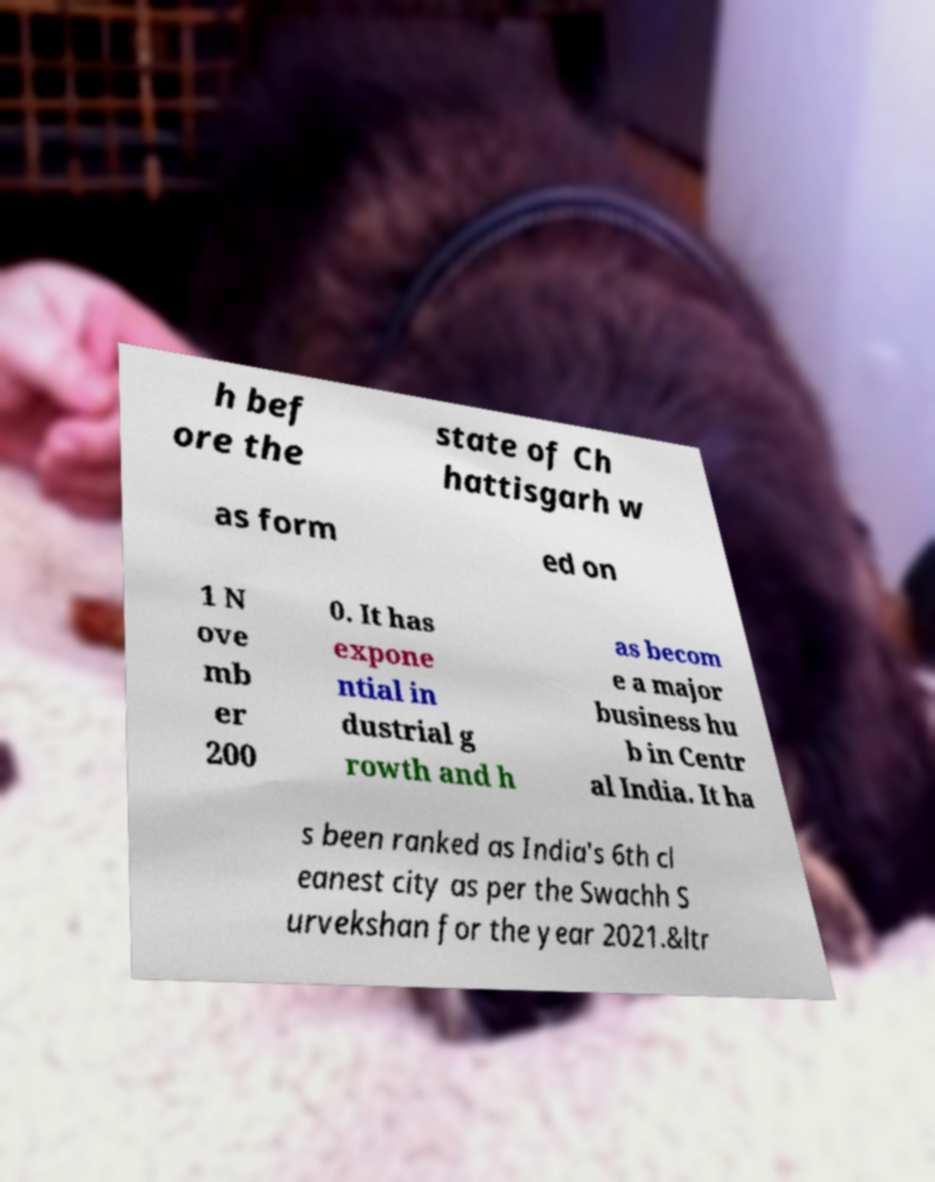There's text embedded in this image that I need extracted. Can you transcribe it verbatim? h bef ore the state of Ch hattisgarh w as form ed on 1 N ove mb er 200 0. It has expone ntial in dustrial g rowth and h as becom e a major business hu b in Centr al India. It ha s been ranked as India's 6th cl eanest city as per the Swachh S urvekshan for the year 2021.&ltr 